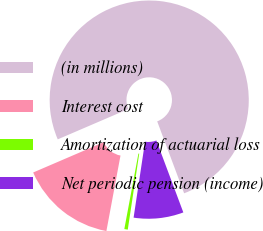Convert chart to OTSL. <chart><loc_0><loc_0><loc_500><loc_500><pie_chart><fcel>(in millions)<fcel>Interest cost<fcel>Amortization of actuarial loss<fcel>Net periodic pension (income)<nl><fcel>75.75%<fcel>15.6%<fcel>0.56%<fcel>8.08%<nl></chart> 